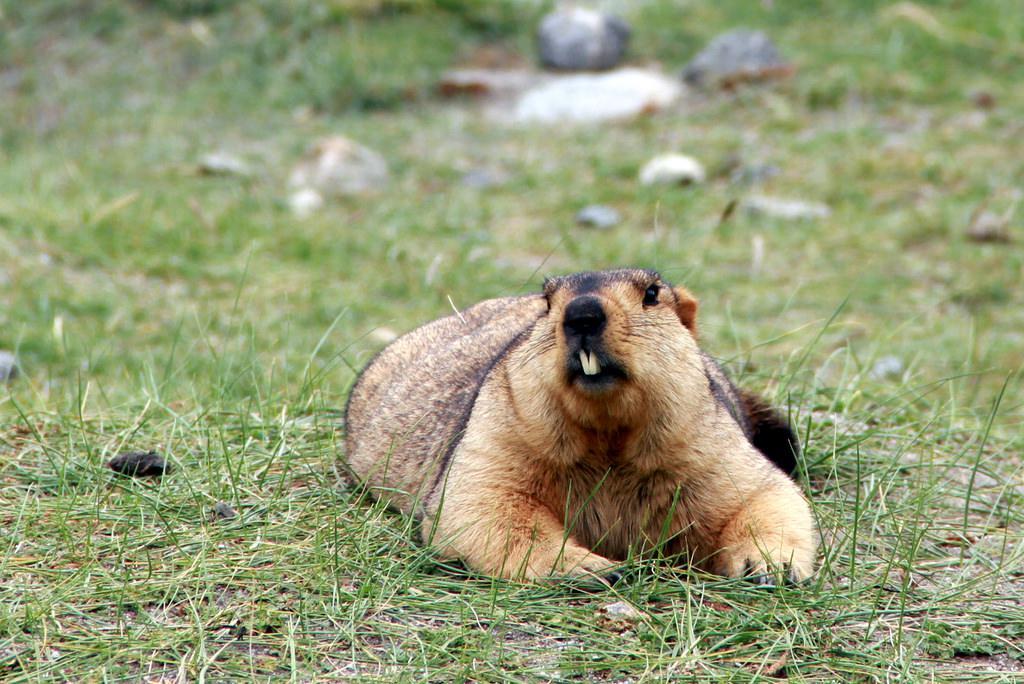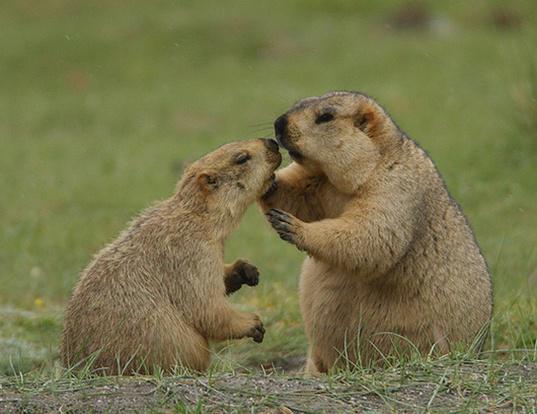The first image is the image on the left, the second image is the image on the right. For the images displayed, is the sentence "There is one gopher on the left, and two gophers being affectionate on the right." factually correct? Answer yes or no. Yes. 